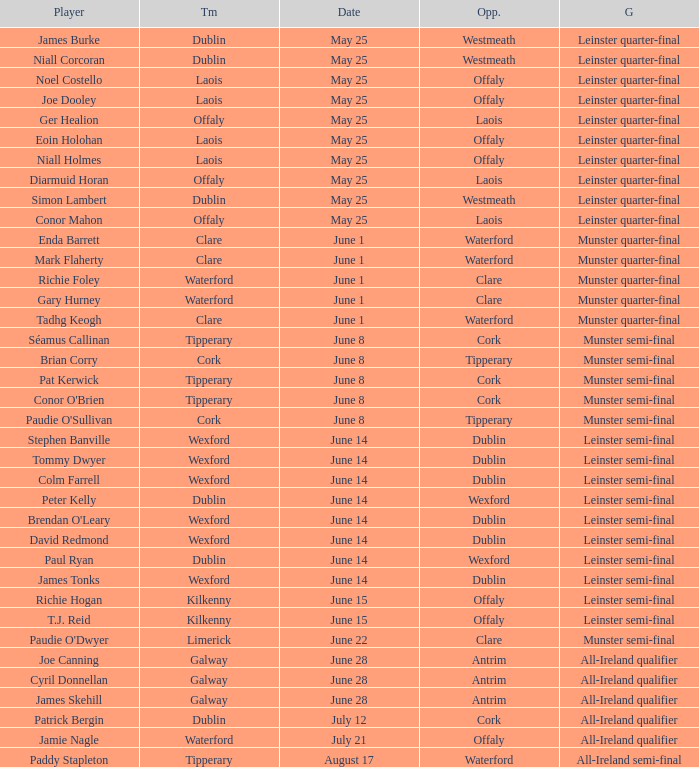Parse the full table. {'header': ['Player', 'Tm', 'Date', 'Opp.', 'G'], 'rows': [['James Burke', 'Dublin', 'May 25', 'Westmeath', 'Leinster quarter-final'], ['Niall Corcoran', 'Dublin', 'May 25', 'Westmeath', 'Leinster quarter-final'], ['Noel Costello', 'Laois', 'May 25', 'Offaly', 'Leinster quarter-final'], ['Joe Dooley', 'Laois', 'May 25', 'Offaly', 'Leinster quarter-final'], ['Ger Healion', 'Offaly', 'May 25', 'Laois', 'Leinster quarter-final'], ['Eoin Holohan', 'Laois', 'May 25', 'Offaly', 'Leinster quarter-final'], ['Niall Holmes', 'Laois', 'May 25', 'Offaly', 'Leinster quarter-final'], ['Diarmuid Horan', 'Offaly', 'May 25', 'Laois', 'Leinster quarter-final'], ['Simon Lambert', 'Dublin', 'May 25', 'Westmeath', 'Leinster quarter-final'], ['Conor Mahon', 'Offaly', 'May 25', 'Laois', 'Leinster quarter-final'], ['Enda Barrett', 'Clare', 'June 1', 'Waterford', 'Munster quarter-final'], ['Mark Flaherty', 'Clare', 'June 1', 'Waterford', 'Munster quarter-final'], ['Richie Foley', 'Waterford', 'June 1', 'Clare', 'Munster quarter-final'], ['Gary Hurney', 'Waterford', 'June 1', 'Clare', 'Munster quarter-final'], ['Tadhg Keogh', 'Clare', 'June 1', 'Waterford', 'Munster quarter-final'], ['Séamus Callinan', 'Tipperary', 'June 8', 'Cork', 'Munster semi-final'], ['Brian Corry', 'Cork', 'June 8', 'Tipperary', 'Munster semi-final'], ['Pat Kerwick', 'Tipperary', 'June 8', 'Cork', 'Munster semi-final'], ["Conor O'Brien", 'Tipperary', 'June 8', 'Cork', 'Munster semi-final'], ["Paudie O'Sullivan", 'Cork', 'June 8', 'Tipperary', 'Munster semi-final'], ['Stephen Banville', 'Wexford', 'June 14', 'Dublin', 'Leinster semi-final'], ['Tommy Dwyer', 'Wexford', 'June 14', 'Dublin', 'Leinster semi-final'], ['Colm Farrell', 'Wexford', 'June 14', 'Dublin', 'Leinster semi-final'], ['Peter Kelly', 'Dublin', 'June 14', 'Wexford', 'Leinster semi-final'], ["Brendan O'Leary", 'Wexford', 'June 14', 'Dublin', 'Leinster semi-final'], ['David Redmond', 'Wexford', 'June 14', 'Dublin', 'Leinster semi-final'], ['Paul Ryan', 'Dublin', 'June 14', 'Wexford', 'Leinster semi-final'], ['James Tonks', 'Wexford', 'June 14', 'Dublin', 'Leinster semi-final'], ['Richie Hogan', 'Kilkenny', 'June 15', 'Offaly', 'Leinster semi-final'], ['T.J. Reid', 'Kilkenny', 'June 15', 'Offaly', 'Leinster semi-final'], ["Paudie O'Dwyer", 'Limerick', 'June 22', 'Clare', 'Munster semi-final'], ['Joe Canning', 'Galway', 'June 28', 'Antrim', 'All-Ireland qualifier'], ['Cyril Donnellan', 'Galway', 'June 28', 'Antrim', 'All-Ireland qualifier'], ['James Skehill', 'Galway', 'June 28', 'Antrim', 'All-Ireland qualifier'], ['Patrick Bergin', 'Dublin', 'July 12', 'Cork', 'All-Ireland qualifier'], ['Jamie Nagle', 'Waterford', 'July 21', 'Offaly', 'All-Ireland qualifier'], ['Paddy Stapleton', 'Tipperary', 'August 17', 'Waterford', 'All-Ireland semi-final']]} What game did Eoin Holohan play in? Leinster quarter-final. 